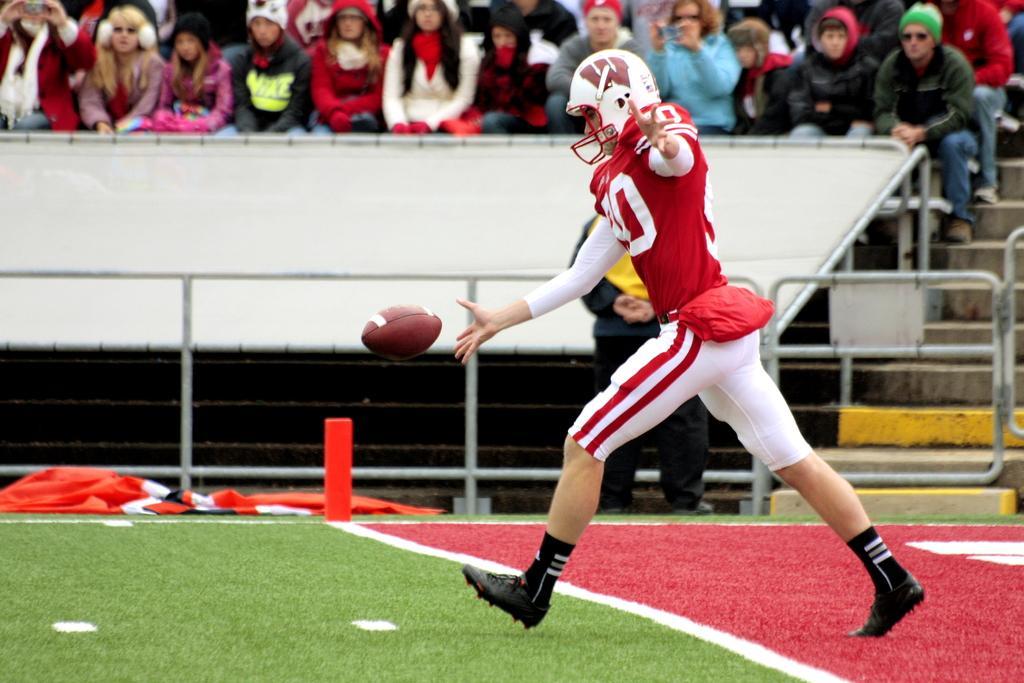How would you summarize this image in a sentence or two? In this image I can see a person wearing red and white color dress. I can see maroon color ball. Back I can see few people sitting on the chair. I can see stairs,fencing and white color board. 